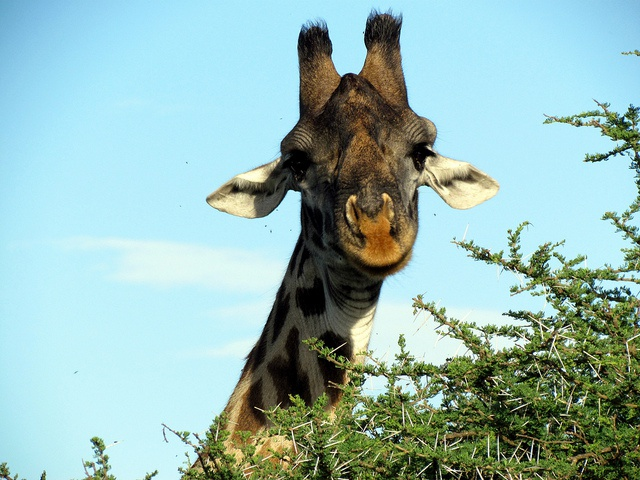Describe the objects in this image and their specific colors. I can see a giraffe in lightblue, black, and olive tones in this image. 